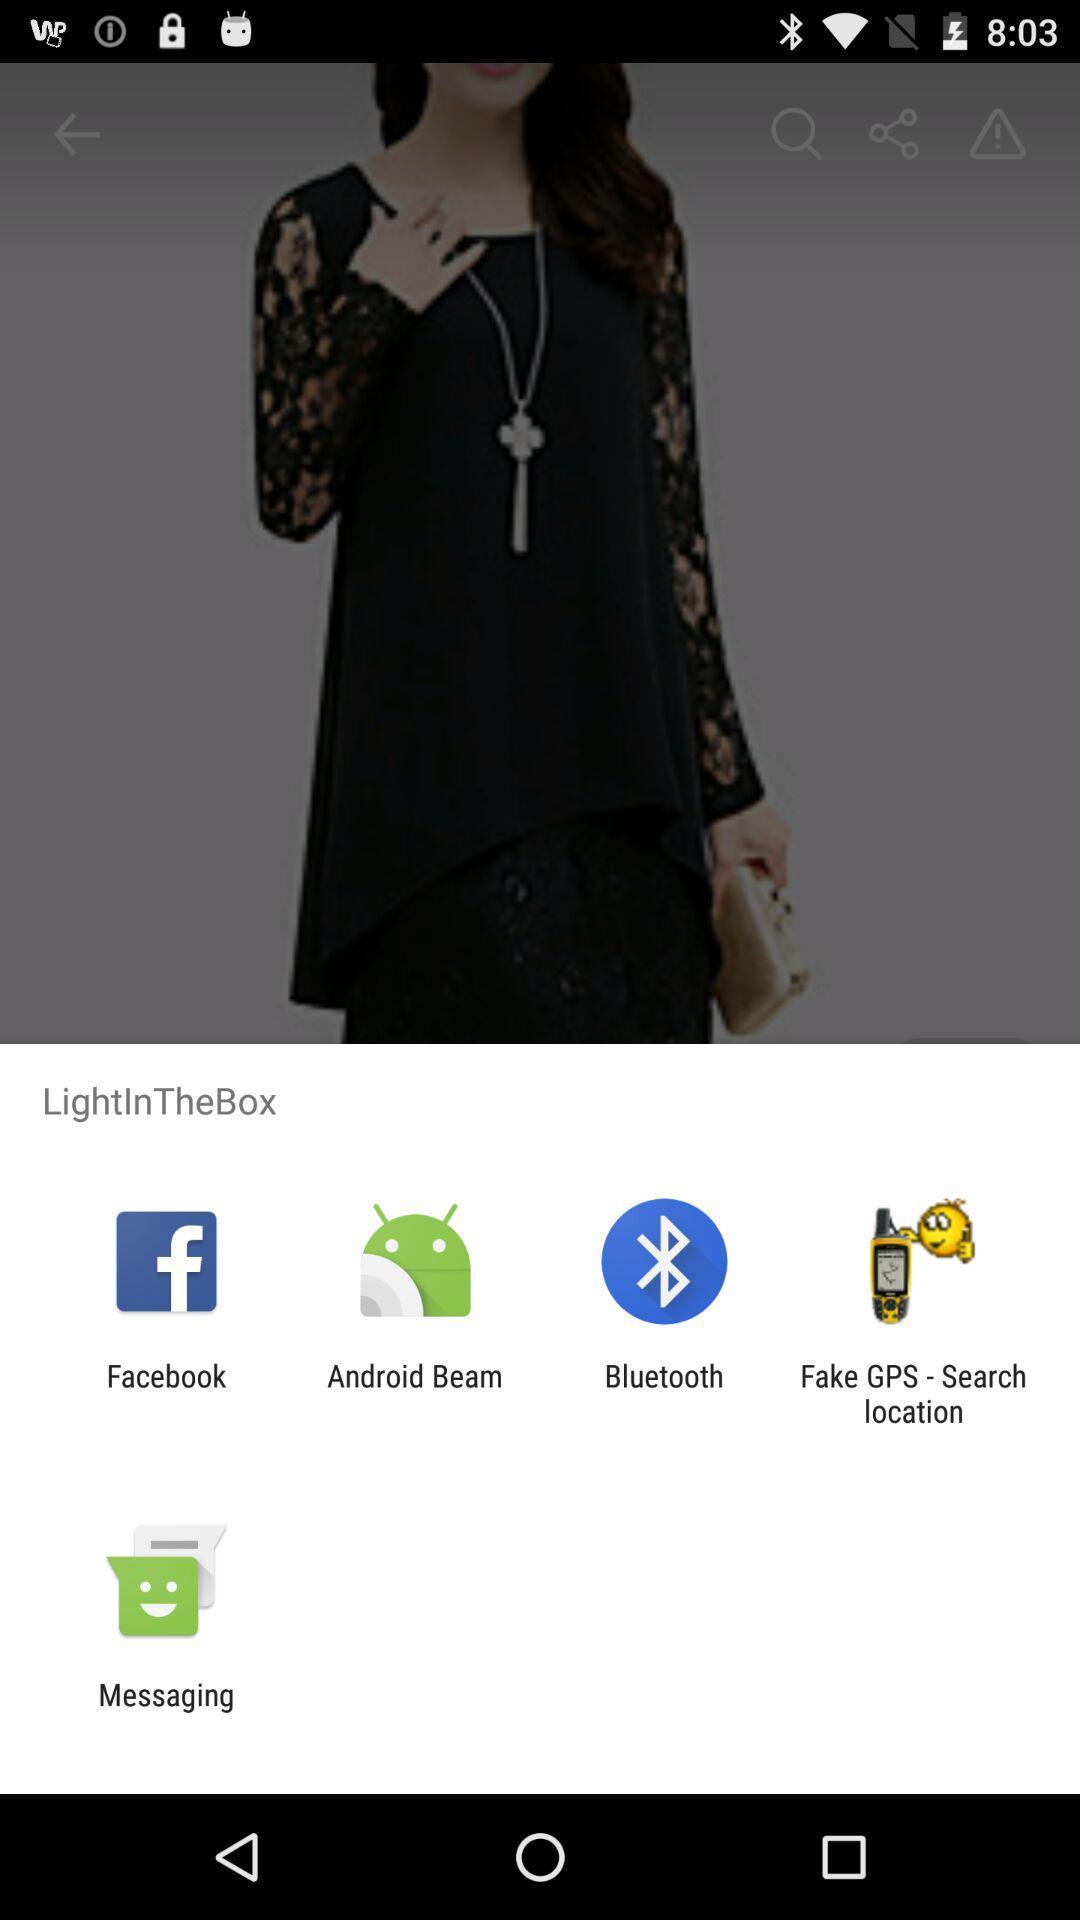What are the sharing options?
When the provided information is insufficient, respond with <no answer>. <no answer> 